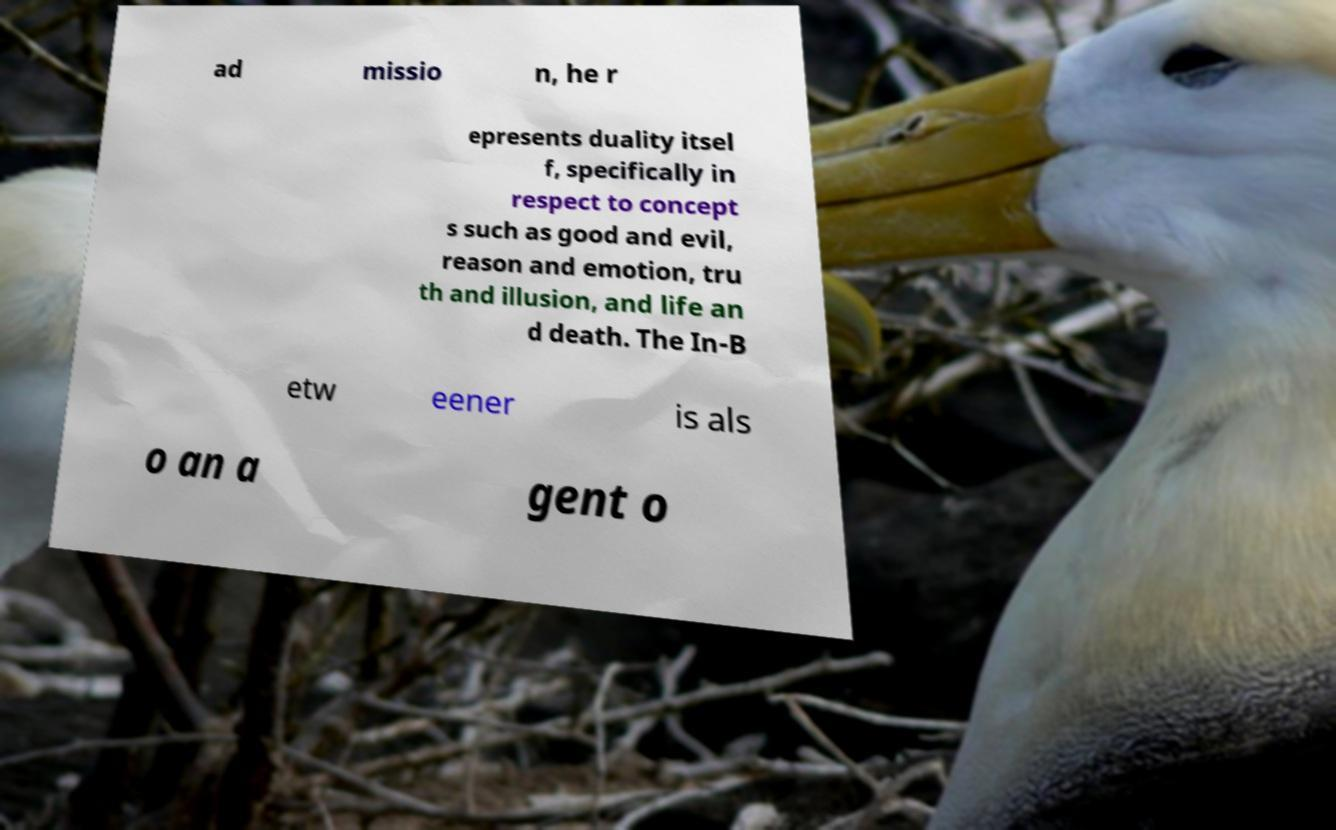Could you assist in decoding the text presented in this image and type it out clearly? ad missio n, he r epresents duality itsel f, specifically in respect to concept s such as good and evil, reason and emotion, tru th and illusion, and life an d death. The In-B etw eener is als o an a gent o 